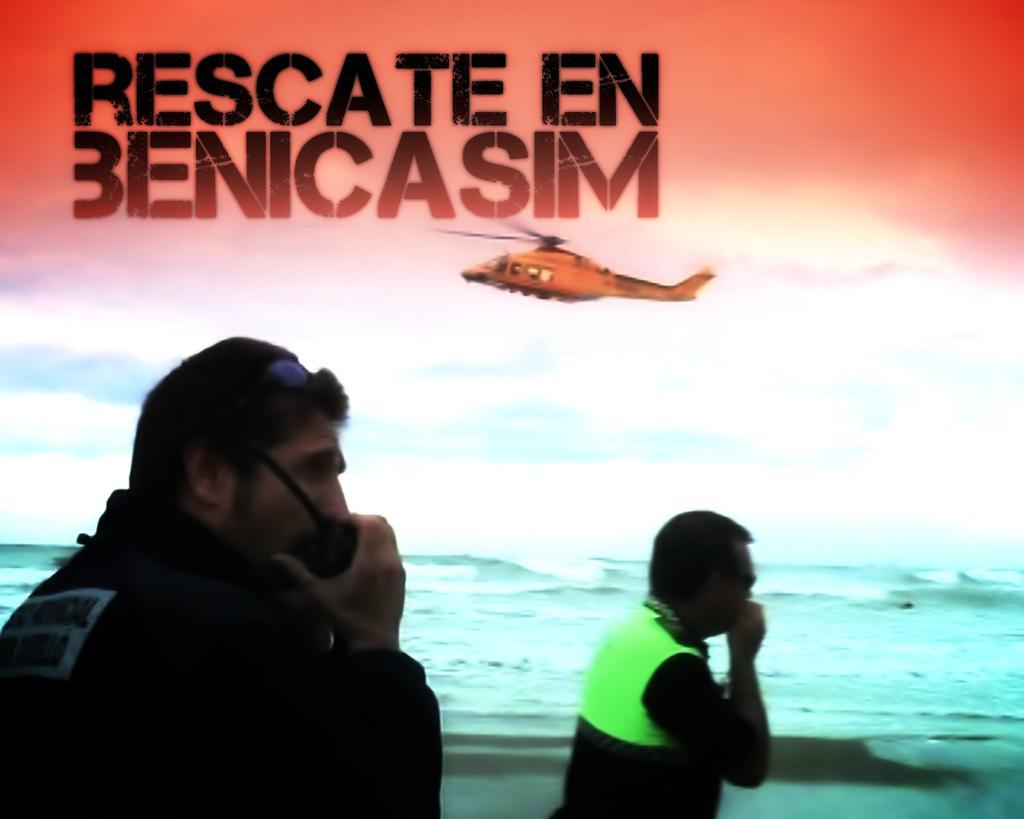In one or two sentences, can you explain what this image depicts? In this picture there are two security persons wearing a black color jacket and talking on the walkie talkie. Behind there is a sea waves. On the top there is a helicopter in the sky and a small quote written on the top right side. 